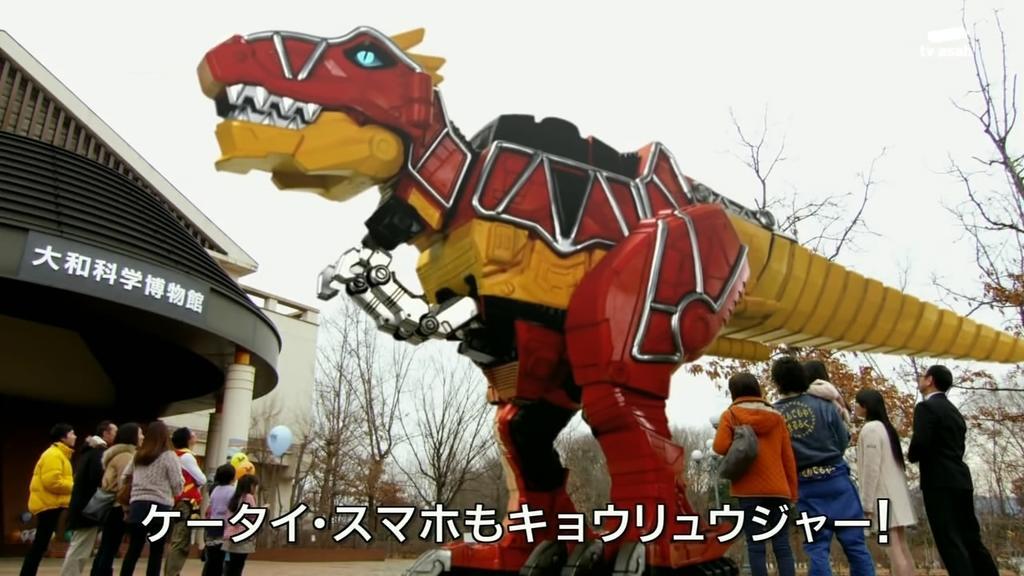How would you summarize this image in a sentence or two? In this image we can see a model of a dinosaur. Left side of the image, one building is there. Background of the image tree are there. The sky is in white color. At the bottom of the image men, women and children are standing and watching to the dinosaur model. We can see watermark at the bottom of the image. 